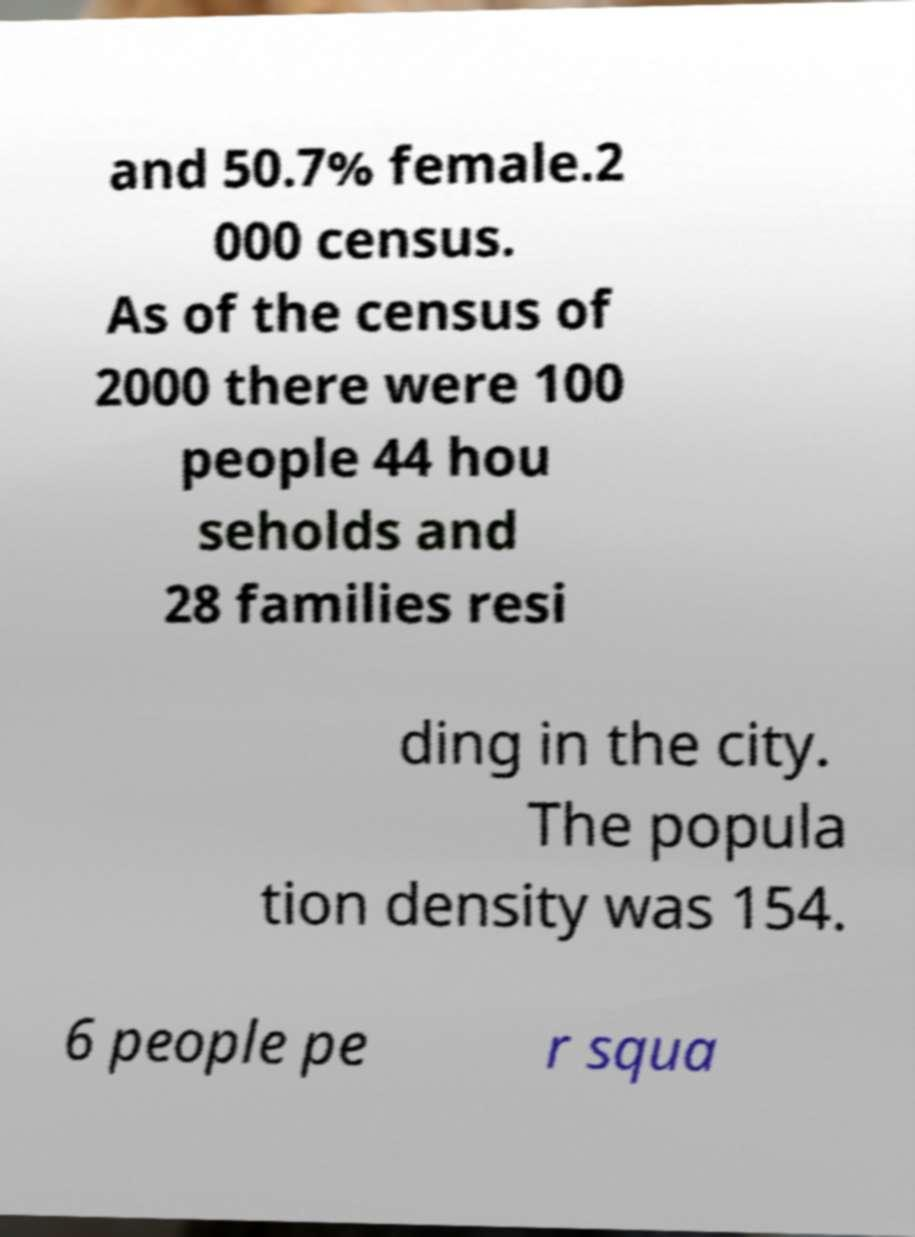There's text embedded in this image that I need extracted. Can you transcribe it verbatim? and 50.7% female.2 000 census. As of the census of 2000 there were 100 people 44 hou seholds and 28 families resi ding in the city. The popula tion density was 154. 6 people pe r squa 